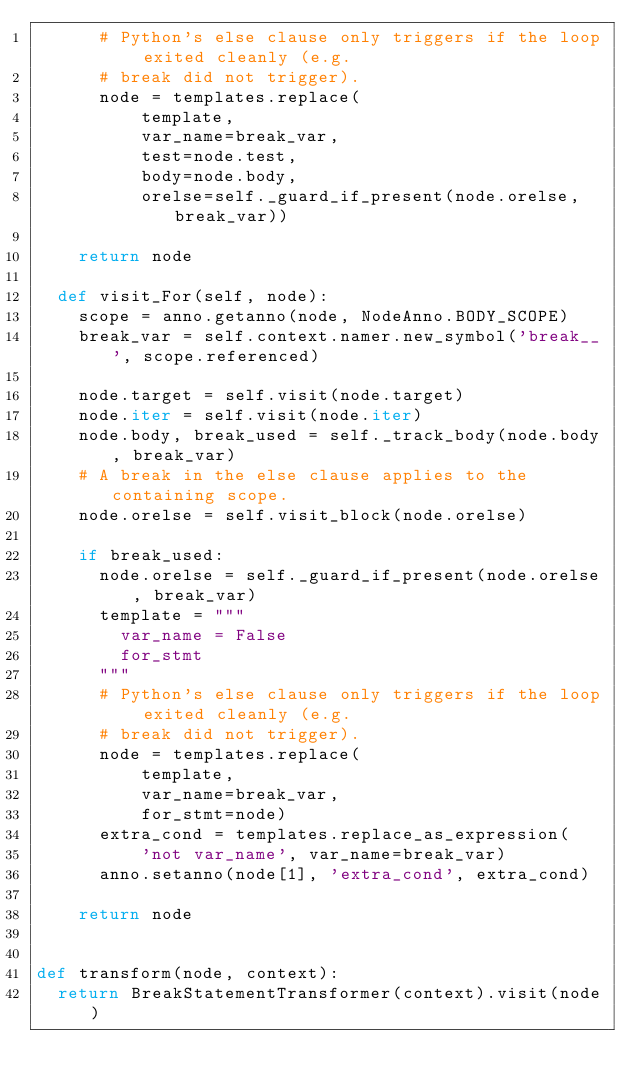<code> <loc_0><loc_0><loc_500><loc_500><_Python_>      # Python's else clause only triggers if the loop exited cleanly (e.g.
      # break did not trigger).
      node = templates.replace(
          template,
          var_name=break_var,
          test=node.test,
          body=node.body,
          orelse=self._guard_if_present(node.orelse, break_var))

    return node

  def visit_For(self, node):
    scope = anno.getanno(node, NodeAnno.BODY_SCOPE)
    break_var = self.context.namer.new_symbol('break__', scope.referenced)

    node.target = self.visit(node.target)
    node.iter = self.visit(node.iter)
    node.body, break_used = self._track_body(node.body, break_var)
    # A break in the else clause applies to the containing scope.
    node.orelse = self.visit_block(node.orelse)

    if break_used:
      node.orelse = self._guard_if_present(node.orelse, break_var)
      template = """
        var_name = False
        for_stmt
      """
      # Python's else clause only triggers if the loop exited cleanly (e.g.
      # break did not trigger).
      node = templates.replace(
          template,
          var_name=break_var,
          for_stmt=node)
      extra_cond = templates.replace_as_expression(
          'not var_name', var_name=break_var)
      anno.setanno(node[1], 'extra_cond', extra_cond)

    return node


def transform(node, context):
  return BreakStatementTransformer(context).visit(node)
</code> 